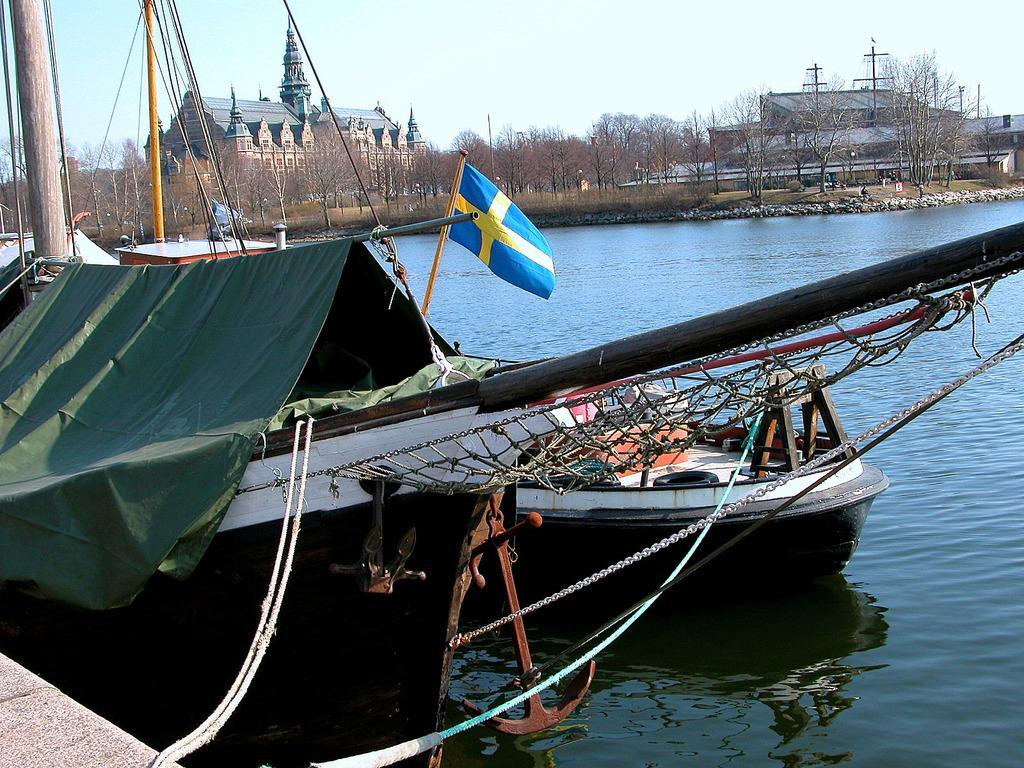How would you summarize this image in a sentence or two? This image consists of boats. At the bottom, there is water. In the background, there are trees. And we can see a building. At the top, there is sky. In the middle, we can see a flag in blue color. 